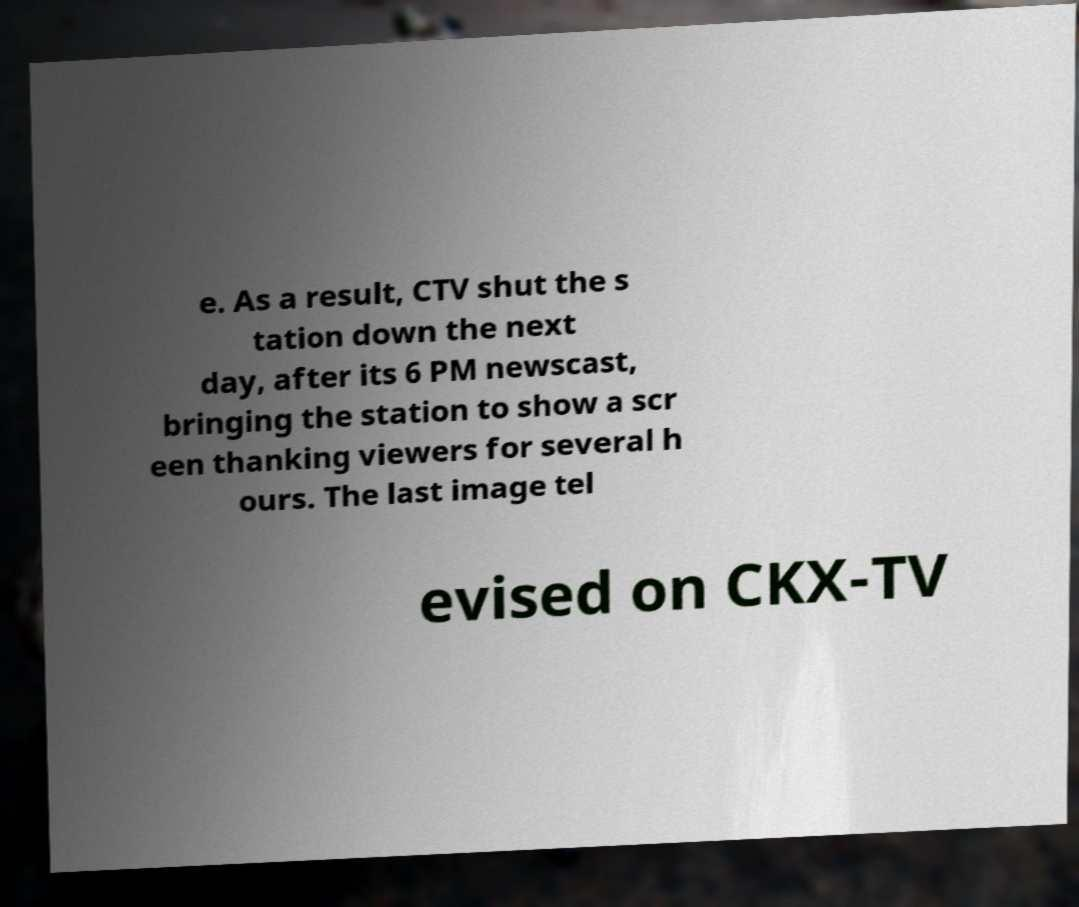Could you assist in decoding the text presented in this image and type it out clearly? e. As a result, CTV shut the s tation down the next day, after its 6 PM newscast, bringing the station to show a scr een thanking viewers for several h ours. The last image tel evised on CKX-TV 